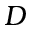Convert formula to latex. <formula><loc_0><loc_0><loc_500><loc_500>D</formula> 